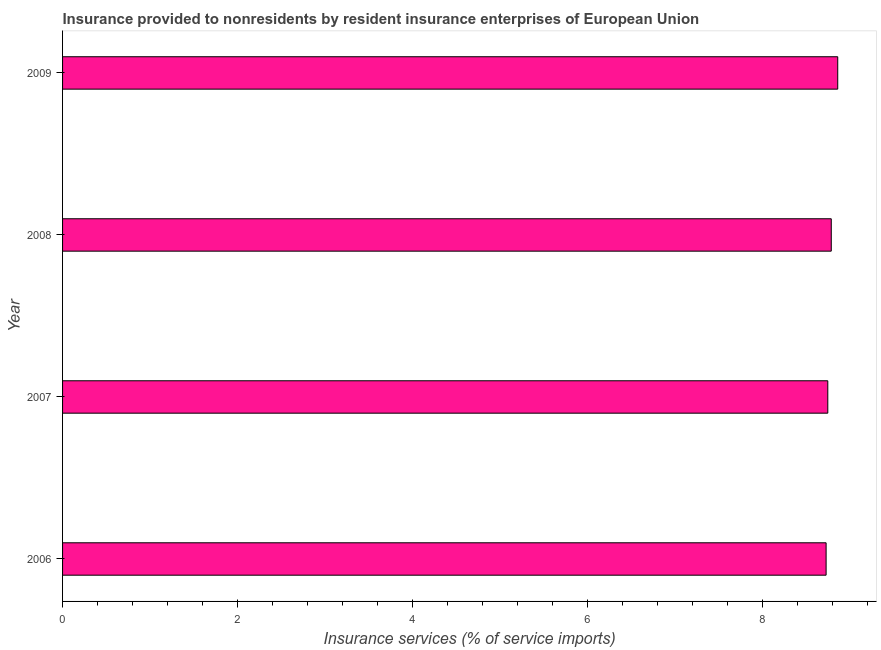Does the graph contain grids?
Provide a succinct answer. No. What is the title of the graph?
Offer a very short reply. Insurance provided to nonresidents by resident insurance enterprises of European Union. What is the label or title of the X-axis?
Offer a terse response. Insurance services (% of service imports). What is the insurance and financial services in 2009?
Give a very brief answer. 8.86. Across all years, what is the maximum insurance and financial services?
Your response must be concise. 8.86. Across all years, what is the minimum insurance and financial services?
Give a very brief answer. 8.73. In which year was the insurance and financial services maximum?
Provide a short and direct response. 2009. What is the sum of the insurance and financial services?
Provide a short and direct response. 35.13. What is the difference between the insurance and financial services in 2007 and 2008?
Keep it short and to the point. -0.04. What is the average insurance and financial services per year?
Ensure brevity in your answer.  8.78. What is the median insurance and financial services?
Your answer should be compact. 8.77. In how many years, is the insurance and financial services greater than 4.4 %?
Your answer should be compact. 4. Do a majority of the years between 2009 and 2006 (inclusive) have insurance and financial services greater than 6.4 %?
Keep it short and to the point. Yes. What is the ratio of the insurance and financial services in 2006 to that in 2008?
Make the answer very short. 0.99. Is the insurance and financial services in 2007 less than that in 2008?
Your answer should be compact. Yes. What is the difference between the highest and the second highest insurance and financial services?
Ensure brevity in your answer.  0.07. Is the sum of the insurance and financial services in 2007 and 2008 greater than the maximum insurance and financial services across all years?
Your response must be concise. Yes. What is the difference between the highest and the lowest insurance and financial services?
Give a very brief answer. 0.13. Are the values on the major ticks of X-axis written in scientific E-notation?
Provide a short and direct response. No. What is the Insurance services (% of service imports) in 2006?
Your answer should be very brief. 8.73. What is the Insurance services (% of service imports) in 2007?
Offer a very short reply. 8.75. What is the Insurance services (% of service imports) in 2008?
Your answer should be compact. 8.79. What is the Insurance services (% of service imports) in 2009?
Your response must be concise. 8.86. What is the difference between the Insurance services (% of service imports) in 2006 and 2007?
Your response must be concise. -0.02. What is the difference between the Insurance services (% of service imports) in 2006 and 2008?
Provide a short and direct response. -0.06. What is the difference between the Insurance services (% of service imports) in 2006 and 2009?
Make the answer very short. -0.13. What is the difference between the Insurance services (% of service imports) in 2007 and 2008?
Your response must be concise. -0.04. What is the difference between the Insurance services (% of service imports) in 2007 and 2009?
Your response must be concise. -0.11. What is the difference between the Insurance services (% of service imports) in 2008 and 2009?
Your response must be concise. -0.07. What is the ratio of the Insurance services (% of service imports) in 2006 to that in 2007?
Provide a short and direct response. 1. What is the ratio of the Insurance services (% of service imports) in 2006 to that in 2008?
Your response must be concise. 0.99. What is the ratio of the Insurance services (% of service imports) in 2006 to that in 2009?
Keep it short and to the point. 0.98. What is the ratio of the Insurance services (% of service imports) in 2008 to that in 2009?
Make the answer very short. 0.99. 